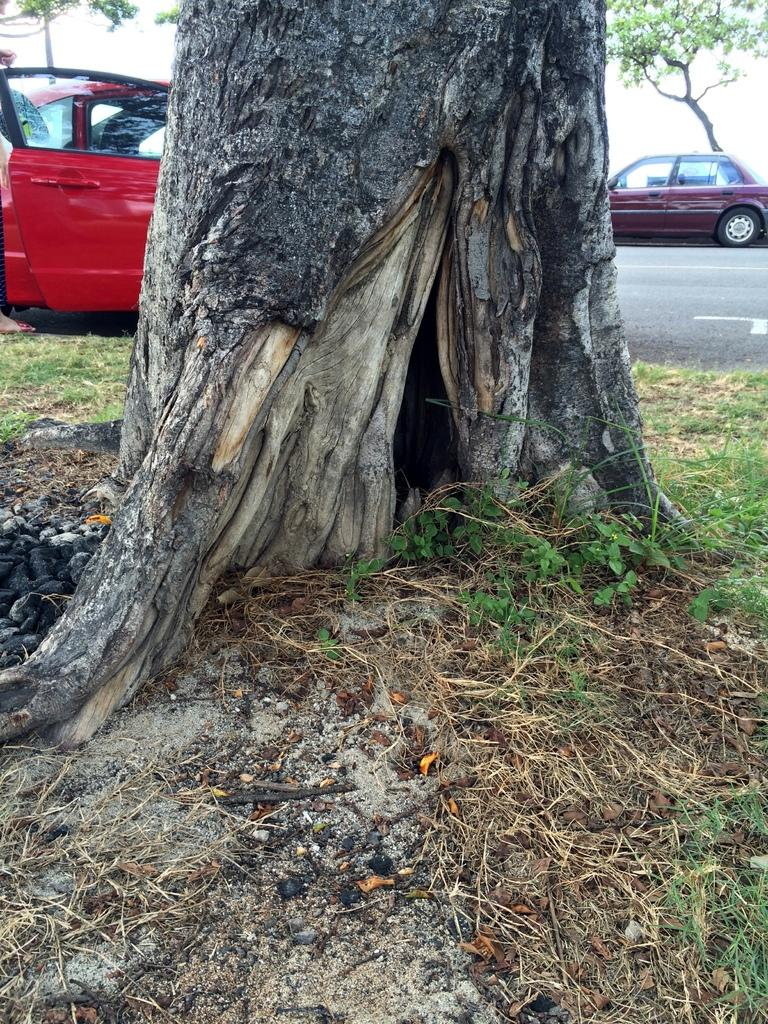What type of vegetation can be seen in the image? There are plants and trees in the image. Are there any vehicles visible in the image? Yes, there are cars in the image. Can you describe the person in the image? There is a person in the top left hand corner of the image. What type of cakes can be seen growing on the trees in the image? There are no cakes present in the image; it features plants, trees, cars, and a person. How does the person in the image pull the cars towards them? The person in the image is not pulling any cars; they are simply standing in the top left hand corner. 